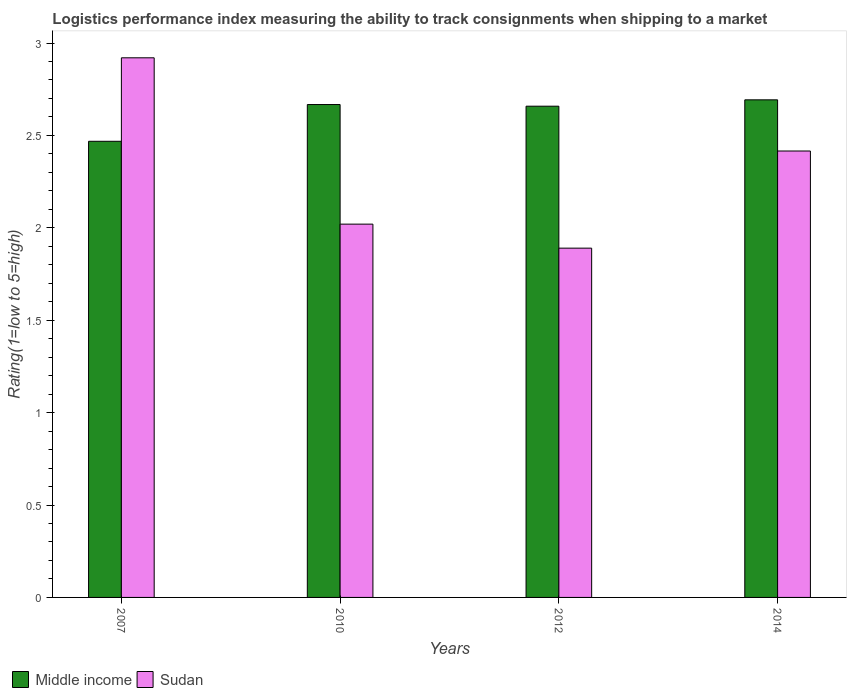How many groups of bars are there?
Your answer should be compact. 4. Are the number of bars on each tick of the X-axis equal?
Your response must be concise. Yes. How many bars are there on the 4th tick from the left?
Offer a very short reply. 2. How many bars are there on the 3rd tick from the right?
Your response must be concise. 2. What is the Logistic performance index in Middle income in 2010?
Your answer should be compact. 2.67. Across all years, what is the maximum Logistic performance index in Sudan?
Offer a terse response. 2.92. Across all years, what is the minimum Logistic performance index in Middle income?
Provide a succinct answer. 2.47. In which year was the Logistic performance index in Sudan maximum?
Keep it short and to the point. 2007. In which year was the Logistic performance index in Middle income minimum?
Give a very brief answer. 2007. What is the total Logistic performance index in Middle income in the graph?
Provide a succinct answer. 10.49. What is the difference between the Logistic performance index in Middle income in 2007 and that in 2010?
Make the answer very short. -0.2. What is the difference between the Logistic performance index in Sudan in 2007 and the Logistic performance index in Middle income in 2010?
Your answer should be compact. 0.25. What is the average Logistic performance index in Sudan per year?
Make the answer very short. 2.31. In the year 2010, what is the difference between the Logistic performance index in Middle income and Logistic performance index in Sudan?
Your response must be concise. 0.65. What is the ratio of the Logistic performance index in Sudan in 2007 to that in 2014?
Your response must be concise. 1.21. Is the difference between the Logistic performance index in Middle income in 2007 and 2010 greater than the difference between the Logistic performance index in Sudan in 2007 and 2010?
Provide a short and direct response. No. What is the difference between the highest and the second highest Logistic performance index in Sudan?
Provide a short and direct response. 0.5. What is the difference between the highest and the lowest Logistic performance index in Middle income?
Your answer should be very brief. 0.22. What does the 2nd bar from the left in 2007 represents?
Make the answer very short. Sudan. What does the 2nd bar from the right in 2010 represents?
Provide a short and direct response. Middle income. How many years are there in the graph?
Your answer should be very brief. 4. Are the values on the major ticks of Y-axis written in scientific E-notation?
Your answer should be very brief. No. Does the graph contain grids?
Keep it short and to the point. No. Where does the legend appear in the graph?
Your answer should be compact. Bottom left. How are the legend labels stacked?
Your response must be concise. Horizontal. What is the title of the graph?
Give a very brief answer. Logistics performance index measuring the ability to track consignments when shipping to a market. What is the label or title of the Y-axis?
Keep it short and to the point. Rating(1=low to 5=high). What is the Rating(1=low to 5=high) in Middle income in 2007?
Provide a succinct answer. 2.47. What is the Rating(1=low to 5=high) in Sudan in 2007?
Make the answer very short. 2.92. What is the Rating(1=low to 5=high) in Middle income in 2010?
Your response must be concise. 2.67. What is the Rating(1=low to 5=high) in Sudan in 2010?
Offer a terse response. 2.02. What is the Rating(1=low to 5=high) in Middle income in 2012?
Ensure brevity in your answer.  2.66. What is the Rating(1=low to 5=high) in Sudan in 2012?
Offer a very short reply. 1.89. What is the Rating(1=low to 5=high) in Middle income in 2014?
Your response must be concise. 2.69. What is the Rating(1=low to 5=high) in Sudan in 2014?
Give a very brief answer. 2.42. Across all years, what is the maximum Rating(1=low to 5=high) of Middle income?
Keep it short and to the point. 2.69. Across all years, what is the maximum Rating(1=low to 5=high) in Sudan?
Offer a very short reply. 2.92. Across all years, what is the minimum Rating(1=low to 5=high) of Middle income?
Provide a short and direct response. 2.47. Across all years, what is the minimum Rating(1=low to 5=high) in Sudan?
Ensure brevity in your answer.  1.89. What is the total Rating(1=low to 5=high) of Middle income in the graph?
Your response must be concise. 10.49. What is the total Rating(1=low to 5=high) of Sudan in the graph?
Your answer should be very brief. 9.25. What is the difference between the Rating(1=low to 5=high) of Middle income in 2007 and that in 2010?
Make the answer very short. -0.2. What is the difference between the Rating(1=low to 5=high) of Sudan in 2007 and that in 2010?
Offer a terse response. 0.9. What is the difference between the Rating(1=low to 5=high) of Middle income in 2007 and that in 2012?
Give a very brief answer. -0.19. What is the difference between the Rating(1=low to 5=high) in Middle income in 2007 and that in 2014?
Offer a very short reply. -0.22. What is the difference between the Rating(1=low to 5=high) of Sudan in 2007 and that in 2014?
Make the answer very short. 0.5. What is the difference between the Rating(1=low to 5=high) of Middle income in 2010 and that in 2012?
Keep it short and to the point. 0.01. What is the difference between the Rating(1=low to 5=high) in Sudan in 2010 and that in 2012?
Keep it short and to the point. 0.13. What is the difference between the Rating(1=low to 5=high) of Middle income in 2010 and that in 2014?
Your answer should be compact. -0.03. What is the difference between the Rating(1=low to 5=high) in Sudan in 2010 and that in 2014?
Provide a short and direct response. -0.4. What is the difference between the Rating(1=low to 5=high) of Middle income in 2012 and that in 2014?
Keep it short and to the point. -0.03. What is the difference between the Rating(1=low to 5=high) of Sudan in 2012 and that in 2014?
Provide a succinct answer. -0.53. What is the difference between the Rating(1=low to 5=high) of Middle income in 2007 and the Rating(1=low to 5=high) of Sudan in 2010?
Keep it short and to the point. 0.45. What is the difference between the Rating(1=low to 5=high) in Middle income in 2007 and the Rating(1=low to 5=high) in Sudan in 2012?
Ensure brevity in your answer.  0.58. What is the difference between the Rating(1=low to 5=high) of Middle income in 2007 and the Rating(1=low to 5=high) of Sudan in 2014?
Offer a very short reply. 0.05. What is the difference between the Rating(1=low to 5=high) of Middle income in 2010 and the Rating(1=low to 5=high) of Sudan in 2012?
Your answer should be very brief. 0.78. What is the difference between the Rating(1=low to 5=high) in Middle income in 2010 and the Rating(1=low to 5=high) in Sudan in 2014?
Make the answer very short. 0.25. What is the difference between the Rating(1=low to 5=high) of Middle income in 2012 and the Rating(1=low to 5=high) of Sudan in 2014?
Provide a short and direct response. 0.24. What is the average Rating(1=low to 5=high) of Middle income per year?
Provide a succinct answer. 2.62. What is the average Rating(1=low to 5=high) of Sudan per year?
Offer a terse response. 2.31. In the year 2007, what is the difference between the Rating(1=low to 5=high) of Middle income and Rating(1=low to 5=high) of Sudan?
Make the answer very short. -0.45. In the year 2010, what is the difference between the Rating(1=low to 5=high) of Middle income and Rating(1=low to 5=high) of Sudan?
Give a very brief answer. 0.65. In the year 2012, what is the difference between the Rating(1=low to 5=high) of Middle income and Rating(1=low to 5=high) of Sudan?
Provide a short and direct response. 0.77. In the year 2014, what is the difference between the Rating(1=low to 5=high) in Middle income and Rating(1=low to 5=high) in Sudan?
Make the answer very short. 0.28. What is the ratio of the Rating(1=low to 5=high) in Middle income in 2007 to that in 2010?
Make the answer very short. 0.93. What is the ratio of the Rating(1=low to 5=high) in Sudan in 2007 to that in 2010?
Your answer should be compact. 1.45. What is the ratio of the Rating(1=low to 5=high) of Sudan in 2007 to that in 2012?
Ensure brevity in your answer.  1.54. What is the ratio of the Rating(1=low to 5=high) of Middle income in 2007 to that in 2014?
Give a very brief answer. 0.92. What is the ratio of the Rating(1=low to 5=high) in Sudan in 2007 to that in 2014?
Provide a succinct answer. 1.21. What is the ratio of the Rating(1=low to 5=high) in Sudan in 2010 to that in 2012?
Offer a very short reply. 1.07. What is the ratio of the Rating(1=low to 5=high) in Middle income in 2010 to that in 2014?
Ensure brevity in your answer.  0.99. What is the ratio of the Rating(1=low to 5=high) of Sudan in 2010 to that in 2014?
Provide a succinct answer. 0.84. What is the ratio of the Rating(1=low to 5=high) in Middle income in 2012 to that in 2014?
Keep it short and to the point. 0.99. What is the ratio of the Rating(1=low to 5=high) of Sudan in 2012 to that in 2014?
Offer a terse response. 0.78. What is the difference between the highest and the second highest Rating(1=low to 5=high) in Middle income?
Offer a very short reply. 0.03. What is the difference between the highest and the second highest Rating(1=low to 5=high) of Sudan?
Provide a succinct answer. 0.5. What is the difference between the highest and the lowest Rating(1=low to 5=high) of Middle income?
Provide a short and direct response. 0.22. What is the difference between the highest and the lowest Rating(1=low to 5=high) of Sudan?
Offer a terse response. 1.03. 